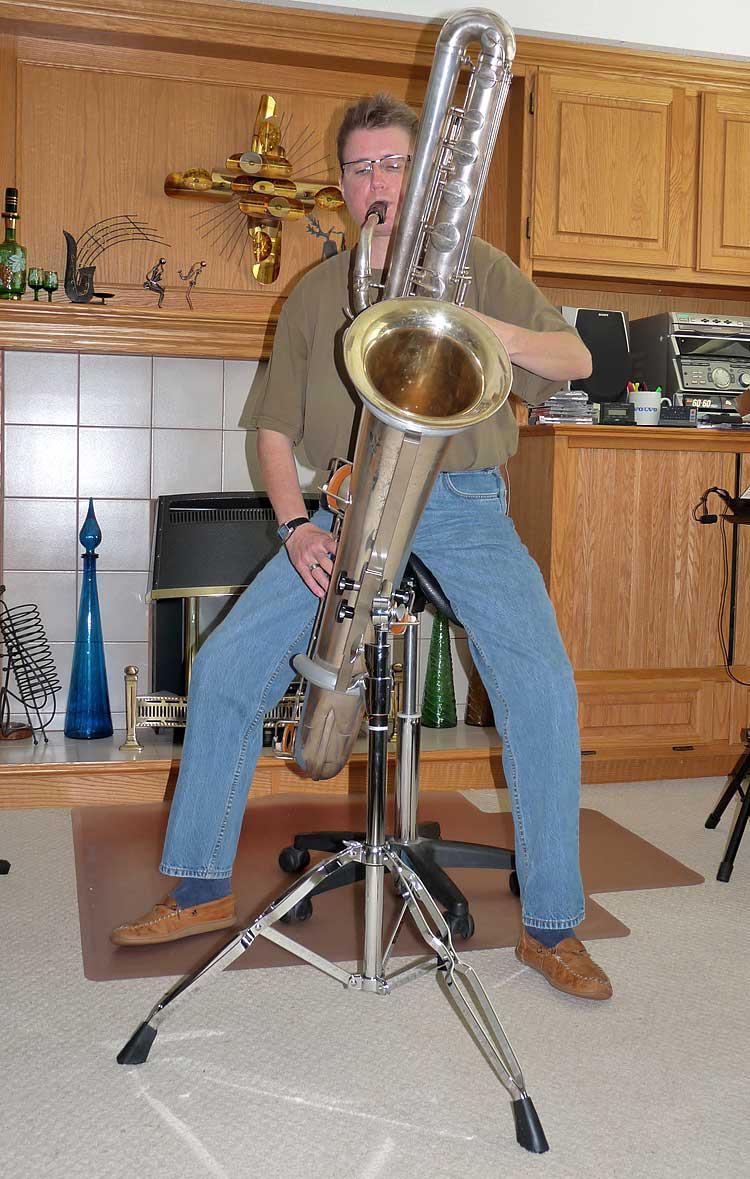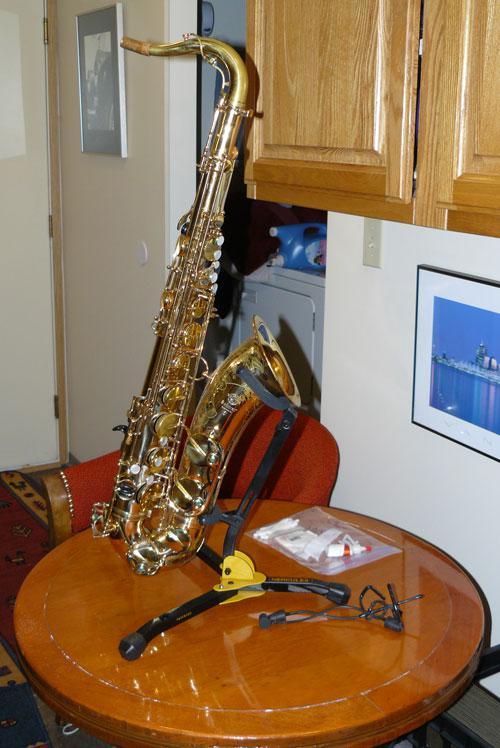The first image is the image on the left, the second image is the image on the right. Considering the images on both sides, is "The left and right image contains the same number of saxophones being held by their stand alone." valid? Answer yes or no. No. The first image is the image on the left, the second image is the image on the right. For the images shown, is this caption "The trombone is facing to the right in the right image." true? Answer yes or no. Yes. 